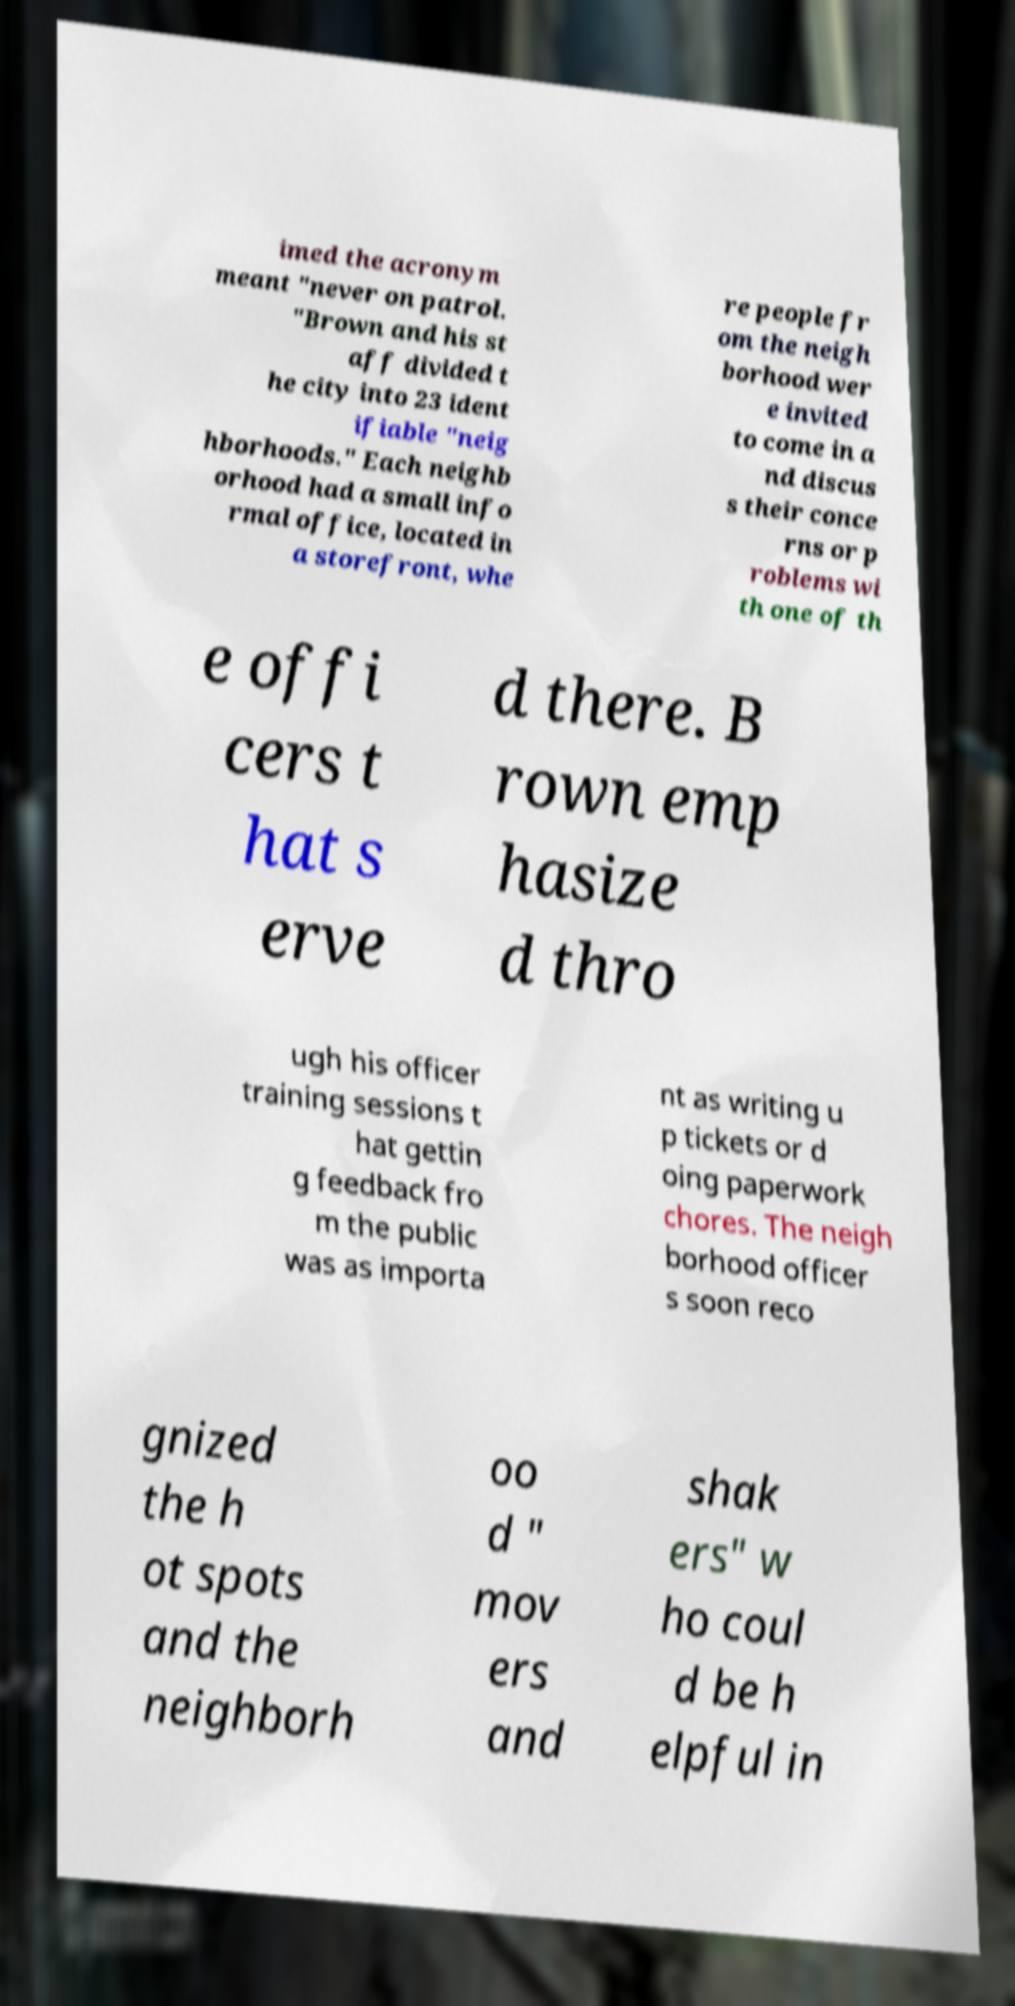Can you read and provide the text displayed in the image?This photo seems to have some interesting text. Can you extract and type it out for me? imed the acronym meant "never on patrol. "Brown and his st aff divided t he city into 23 ident ifiable "neig hborhoods." Each neighb orhood had a small info rmal office, located in a storefront, whe re people fr om the neigh borhood wer e invited to come in a nd discus s their conce rns or p roblems wi th one of th e offi cers t hat s erve d there. B rown emp hasize d thro ugh his officer training sessions t hat gettin g feedback fro m the public was as importa nt as writing u p tickets or d oing paperwork chores. The neigh borhood officer s soon reco gnized the h ot spots and the neighborh oo d " mov ers and shak ers" w ho coul d be h elpful in 